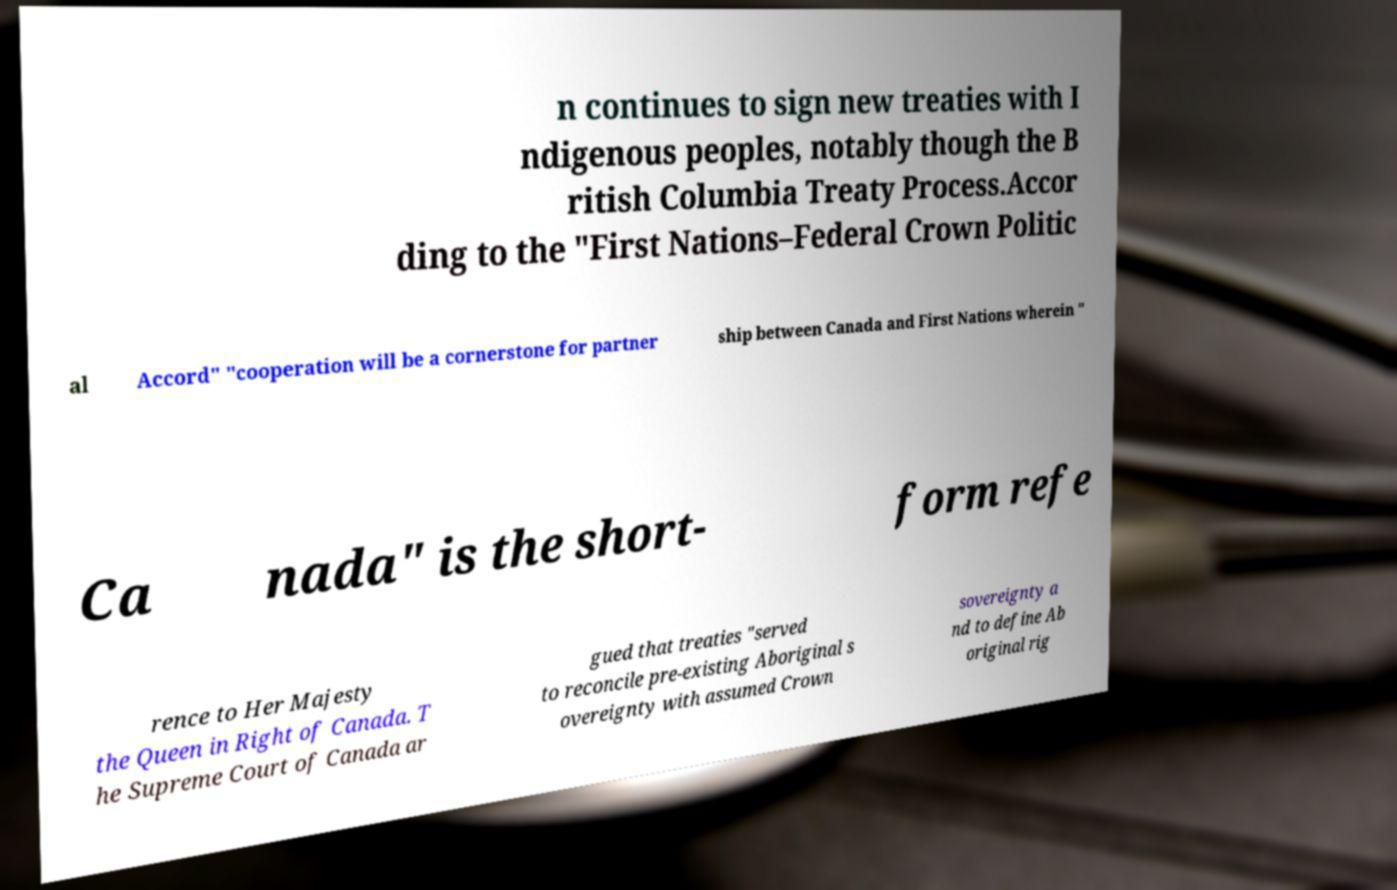Could you assist in decoding the text presented in this image and type it out clearly? n continues to sign new treaties with I ndigenous peoples, notably though the B ritish Columbia Treaty Process.Accor ding to the "First Nations–Federal Crown Politic al Accord" "cooperation will be a cornerstone for partner ship between Canada and First Nations wherein " Ca nada" is the short- form refe rence to Her Majesty the Queen in Right of Canada. T he Supreme Court of Canada ar gued that treaties "served to reconcile pre-existing Aboriginal s overeignty with assumed Crown sovereignty a nd to define Ab original rig 